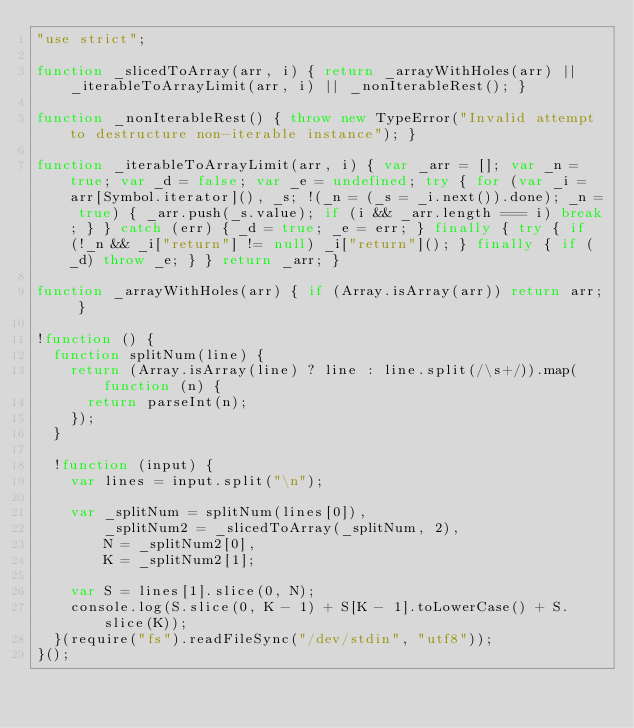Convert code to text. <code><loc_0><loc_0><loc_500><loc_500><_JavaScript_>"use strict";

function _slicedToArray(arr, i) { return _arrayWithHoles(arr) || _iterableToArrayLimit(arr, i) || _nonIterableRest(); }

function _nonIterableRest() { throw new TypeError("Invalid attempt to destructure non-iterable instance"); }

function _iterableToArrayLimit(arr, i) { var _arr = []; var _n = true; var _d = false; var _e = undefined; try { for (var _i = arr[Symbol.iterator](), _s; !(_n = (_s = _i.next()).done); _n = true) { _arr.push(_s.value); if (i && _arr.length === i) break; } } catch (err) { _d = true; _e = err; } finally { try { if (!_n && _i["return"] != null) _i["return"](); } finally { if (_d) throw _e; } } return _arr; }

function _arrayWithHoles(arr) { if (Array.isArray(arr)) return arr; }

!function () {
  function splitNum(line) {
    return (Array.isArray(line) ? line : line.split(/\s+/)).map(function (n) {
      return parseInt(n);
    });
  }

  !function (input) {
    var lines = input.split("\n");

    var _splitNum = splitNum(lines[0]),
        _splitNum2 = _slicedToArray(_splitNum, 2),
        N = _splitNum2[0],
        K = _splitNum2[1];

    var S = lines[1].slice(0, N);
    console.log(S.slice(0, K - 1) + S[K - 1].toLowerCase() + S.slice(K));
  }(require("fs").readFileSync("/dev/stdin", "utf8"));
}();
</code> 